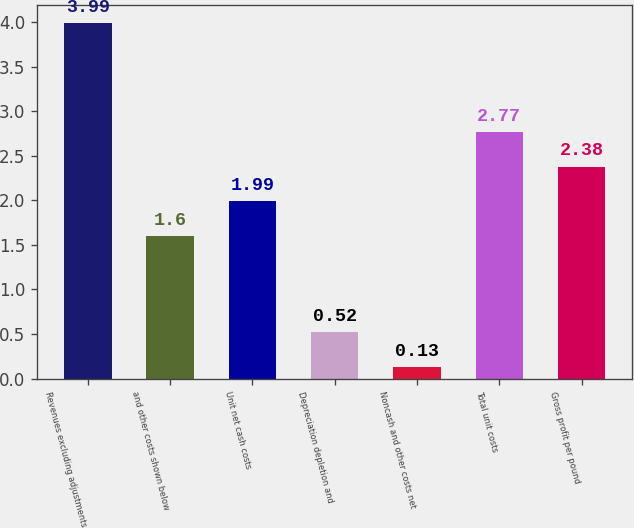Convert chart to OTSL. <chart><loc_0><loc_0><loc_500><loc_500><bar_chart><fcel>Revenues excluding adjustments<fcel>and other costs shown below<fcel>Unit net cash costs<fcel>Depreciation depletion and<fcel>Noncash and other costs net<fcel>Total unit costs<fcel>Gross profit per pound<nl><fcel>3.99<fcel>1.6<fcel>1.99<fcel>0.52<fcel>0.13<fcel>2.77<fcel>2.38<nl></chart> 